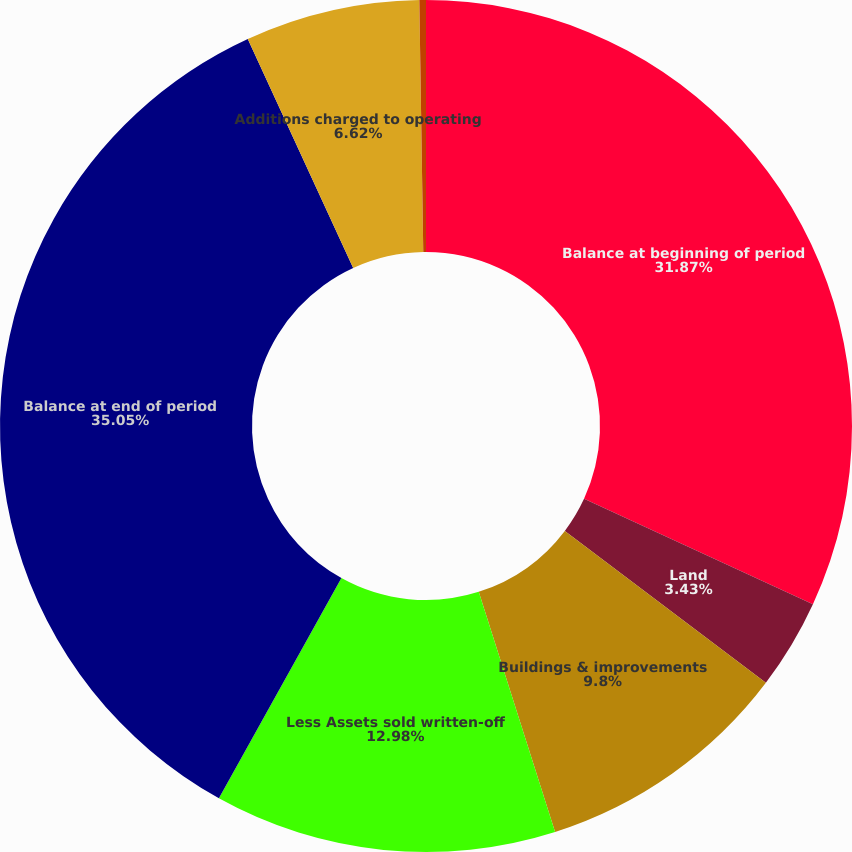Convert chart. <chart><loc_0><loc_0><loc_500><loc_500><pie_chart><fcel>Balance at beginning of period<fcel>Land<fcel>Buildings & improvements<fcel>Less Assets sold written-off<fcel>Balance at end of period<fcel>Additions charged to operating<fcel>Less Accumulated depreciation<nl><fcel>31.87%<fcel>3.43%<fcel>9.8%<fcel>12.98%<fcel>35.05%<fcel>6.62%<fcel>0.25%<nl></chart> 